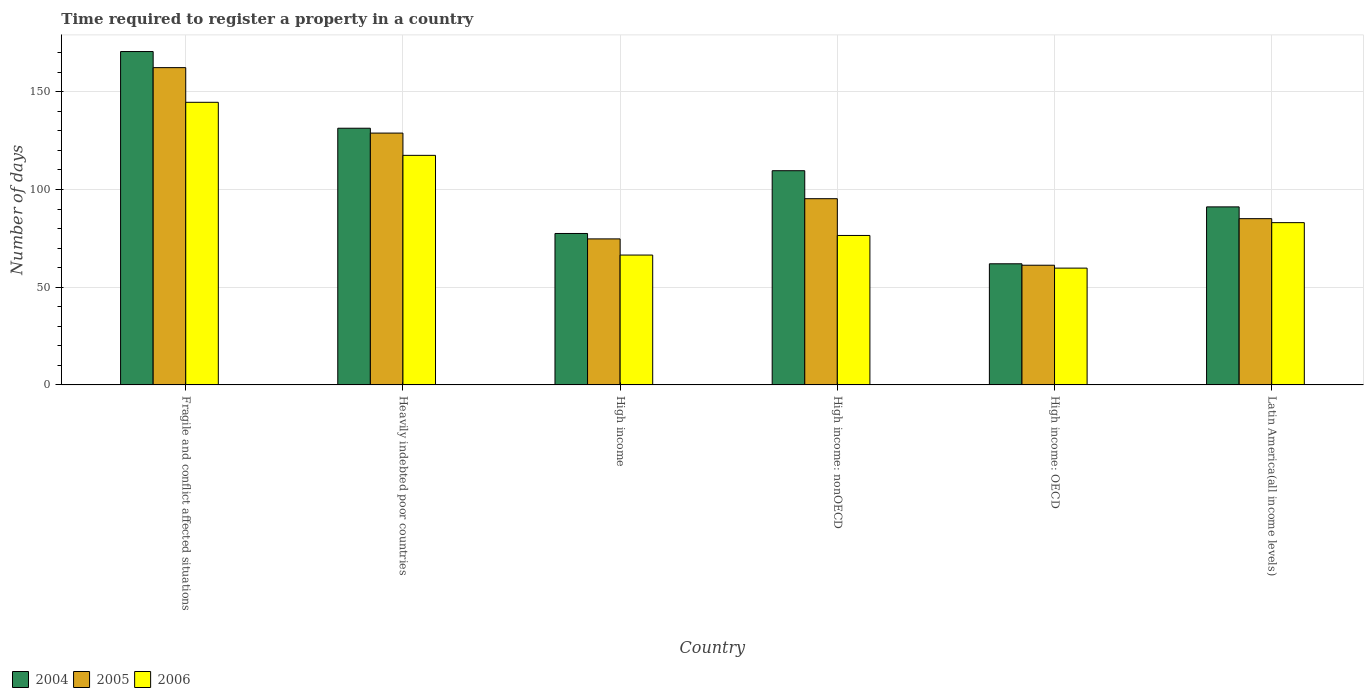Are the number of bars per tick equal to the number of legend labels?
Offer a terse response. Yes. How many bars are there on the 4th tick from the right?
Provide a short and direct response. 3. What is the label of the 1st group of bars from the left?
Provide a succinct answer. Fragile and conflict affected situations. What is the number of days required to register a property in 2006 in High income?
Provide a succinct answer. 66.45. Across all countries, what is the maximum number of days required to register a property in 2004?
Offer a terse response. 170.59. Across all countries, what is the minimum number of days required to register a property in 2005?
Ensure brevity in your answer.  61.24. In which country was the number of days required to register a property in 2006 maximum?
Your answer should be compact. Fragile and conflict affected situations. In which country was the number of days required to register a property in 2005 minimum?
Provide a short and direct response. High income: OECD. What is the total number of days required to register a property in 2004 in the graph?
Your answer should be compact. 642.12. What is the difference between the number of days required to register a property in 2005 in Fragile and conflict affected situations and that in Latin America(all income levels)?
Your answer should be very brief. 77.29. What is the difference between the number of days required to register a property in 2006 in High income: OECD and the number of days required to register a property in 2005 in Heavily indebted poor countries?
Your response must be concise. -69.1. What is the average number of days required to register a property in 2005 per country?
Make the answer very short. 101.26. What is the difference between the number of days required to register a property of/in 2004 and number of days required to register a property of/in 2006 in High income: OECD?
Your answer should be very brief. 2.22. In how many countries, is the number of days required to register a property in 2005 greater than 140 days?
Keep it short and to the point. 1. What is the ratio of the number of days required to register a property in 2006 in High income: OECD to that in Latin America(all income levels)?
Ensure brevity in your answer.  0.72. Is the number of days required to register a property in 2005 in Heavily indebted poor countries less than that in High income: OECD?
Ensure brevity in your answer.  No. Is the difference between the number of days required to register a property in 2004 in High income and High income: OECD greater than the difference between the number of days required to register a property in 2006 in High income and High income: OECD?
Ensure brevity in your answer.  Yes. What is the difference between the highest and the second highest number of days required to register a property in 2006?
Keep it short and to the point. 61.58. What is the difference between the highest and the lowest number of days required to register a property in 2005?
Your answer should be compact. 101.12. In how many countries, is the number of days required to register a property in 2004 greater than the average number of days required to register a property in 2004 taken over all countries?
Provide a short and direct response. 3. What does the 2nd bar from the right in Heavily indebted poor countries represents?
Your answer should be very brief. 2005. Is it the case that in every country, the sum of the number of days required to register a property in 2006 and number of days required to register a property in 2005 is greater than the number of days required to register a property in 2004?
Offer a terse response. Yes. How many bars are there?
Offer a terse response. 18. How many countries are there in the graph?
Your answer should be compact. 6. Are the values on the major ticks of Y-axis written in scientific E-notation?
Offer a terse response. No. Does the graph contain any zero values?
Your answer should be very brief. No. How many legend labels are there?
Your response must be concise. 3. What is the title of the graph?
Provide a short and direct response. Time required to register a property in a country. Does "2001" appear as one of the legend labels in the graph?
Offer a very short reply. No. What is the label or title of the Y-axis?
Keep it short and to the point. Number of days. What is the Number of days in 2004 in Fragile and conflict affected situations?
Give a very brief answer. 170.59. What is the Number of days in 2005 in Fragile and conflict affected situations?
Your response must be concise. 162.36. What is the Number of days in 2006 in Fragile and conflict affected situations?
Ensure brevity in your answer.  144.62. What is the Number of days of 2004 in Heavily indebted poor countries?
Keep it short and to the point. 131.35. What is the Number of days of 2005 in Heavily indebted poor countries?
Provide a succinct answer. 128.86. What is the Number of days in 2006 in Heavily indebted poor countries?
Make the answer very short. 117.47. What is the Number of days in 2004 in High income?
Your answer should be compact. 77.49. What is the Number of days in 2005 in High income?
Ensure brevity in your answer.  74.72. What is the Number of days of 2006 in High income?
Your answer should be compact. 66.45. What is the Number of days of 2004 in High income: nonOECD?
Offer a very short reply. 109.61. What is the Number of days in 2005 in High income: nonOECD?
Your answer should be compact. 95.29. What is the Number of days in 2006 in High income: nonOECD?
Keep it short and to the point. 76.47. What is the Number of days of 2004 in High income: OECD?
Offer a terse response. 61.98. What is the Number of days in 2005 in High income: OECD?
Provide a succinct answer. 61.24. What is the Number of days in 2006 in High income: OECD?
Your answer should be very brief. 59.77. What is the Number of days in 2004 in Latin America(all income levels)?
Give a very brief answer. 91.1. What is the Number of days of 2005 in Latin America(all income levels)?
Provide a short and direct response. 85.07. What is the Number of days of 2006 in Latin America(all income levels)?
Provide a succinct answer. 83.03. Across all countries, what is the maximum Number of days of 2004?
Keep it short and to the point. 170.59. Across all countries, what is the maximum Number of days of 2005?
Your response must be concise. 162.36. Across all countries, what is the maximum Number of days of 2006?
Offer a terse response. 144.62. Across all countries, what is the minimum Number of days in 2004?
Your answer should be compact. 61.98. Across all countries, what is the minimum Number of days in 2005?
Provide a succinct answer. 61.24. Across all countries, what is the minimum Number of days of 2006?
Keep it short and to the point. 59.77. What is the total Number of days of 2004 in the graph?
Provide a short and direct response. 642.12. What is the total Number of days in 2005 in the graph?
Keep it short and to the point. 607.54. What is the total Number of days of 2006 in the graph?
Ensure brevity in your answer.  547.82. What is the difference between the Number of days in 2004 in Fragile and conflict affected situations and that in Heavily indebted poor countries?
Your answer should be compact. 39.24. What is the difference between the Number of days in 2005 in Fragile and conflict affected situations and that in Heavily indebted poor countries?
Your response must be concise. 33.5. What is the difference between the Number of days in 2006 in Fragile and conflict affected situations and that in Heavily indebted poor countries?
Offer a terse response. 27.14. What is the difference between the Number of days of 2004 in Fragile and conflict affected situations and that in High income?
Your response must be concise. 93.1. What is the difference between the Number of days in 2005 in Fragile and conflict affected situations and that in High income?
Your answer should be very brief. 87.64. What is the difference between the Number of days of 2006 in Fragile and conflict affected situations and that in High income?
Give a very brief answer. 78.17. What is the difference between the Number of days of 2004 in Fragile and conflict affected situations and that in High income: nonOECD?
Ensure brevity in your answer.  60.98. What is the difference between the Number of days in 2005 in Fragile and conflict affected situations and that in High income: nonOECD?
Your response must be concise. 67.07. What is the difference between the Number of days in 2006 in Fragile and conflict affected situations and that in High income: nonOECD?
Make the answer very short. 68.14. What is the difference between the Number of days in 2004 in Fragile and conflict affected situations and that in High income: OECD?
Ensure brevity in your answer.  108.61. What is the difference between the Number of days of 2005 in Fragile and conflict affected situations and that in High income: OECD?
Offer a terse response. 101.12. What is the difference between the Number of days in 2006 in Fragile and conflict affected situations and that in High income: OECD?
Make the answer very short. 84.85. What is the difference between the Number of days of 2004 in Fragile and conflict affected situations and that in Latin America(all income levels)?
Keep it short and to the point. 79.49. What is the difference between the Number of days of 2005 in Fragile and conflict affected situations and that in Latin America(all income levels)?
Give a very brief answer. 77.29. What is the difference between the Number of days in 2006 in Fragile and conflict affected situations and that in Latin America(all income levels)?
Ensure brevity in your answer.  61.58. What is the difference between the Number of days of 2004 in Heavily indebted poor countries and that in High income?
Your answer should be very brief. 53.86. What is the difference between the Number of days of 2005 in Heavily indebted poor countries and that in High income?
Provide a short and direct response. 54.15. What is the difference between the Number of days of 2006 in Heavily indebted poor countries and that in High income?
Offer a terse response. 51.02. What is the difference between the Number of days of 2004 in Heavily indebted poor countries and that in High income: nonOECD?
Provide a succinct answer. 21.75. What is the difference between the Number of days in 2005 in Heavily indebted poor countries and that in High income: nonOECD?
Give a very brief answer. 33.58. What is the difference between the Number of days of 2006 in Heavily indebted poor countries and that in High income: nonOECD?
Make the answer very short. 41. What is the difference between the Number of days of 2004 in Heavily indebted poor countries and that in High income: OECD?
Your answer should be compact. 69.37. What is the difference between the Number of days in 2005 in Heavily indebted poor countries and that in High income: OECD?
Offer a terse response. 67.62. What is the difference between the Number of days in 2006 in Heavily indebted poor countries and that in High income: OECD?
Ensure brevity in your answer.  57.71. What is the difference between the Number of days of 2004 in Heavily indebted poor countries and that in Latin America(all income levels)?
Your answer should be very brief. 40.25. What is the difference between the Number of days of 2005 in Heavily indebted poor countries and that in Latin America(all income levels)?
Give a very brief answer. 43.8. What is the difference between the Number of days of 2006 in Heavily indebted poor countries and that in Latin America(all income levels)?
Your answer should be compact. 34.44. What is the difference between the Number of days of 2004 in High income and that in High income: nonOECD?
Offer a very short reply. -32.12. What is the difference between the Number of days of 2005 in High income and that in High income: nonOECD?
Offer a very short reply. -20.57. What is the difference between the Number of days of 2006 in High income and that in High income: nonOECD?
Your answer should be compact. -10.03. What is the difference between the Number of days of 2004 in High income and that in High income: OECD?
Make the answer very short. 15.51. What is the difference between the Number of days in 2005 in High income and that in High income: OECD?
Give a very brief answer. 13.48. What is the difference between the Number of days in 2006 in High income and that in High income: OECD?
Offer a very short reply. 6.68. What is the difference between the Number of days in 2004 in High income and that in Latin America(all income levels)?
Your response must be concise. -13.61. What is the difference between the Number of days in 2005 in High income and that in Latin America(all income levels)?
Make the answer very short. -10.35. What is the difference between the Number of days in 2006 in High income and that in Latin America(all income levels)?
Provide a succinct answer. -16.58. What is the difference between the Number of days in 2004 in High income: nonOECD and that in High income: OECD?
Provide a short and direct response. 47.62. What is the difference between the Number of days of 2005 in High income: nonOECD and that in High income: OECD?
Provide a short and direct response. 34.05. What is the difference between the Number of days of 2006 in High income: nonOECD and that in High income: OECD?
Keep it short and to the point. 16.71. What is the difference between the Number of days of 2004 in High income: nonOECD and that in Latin America(all income levels)?
Ensure brevity in your answer.  18.51. What is the difference between the Number of days in 2005 in High income: nonOECD and that in Latin America(all income levels)?
Offer a terse response. 10.22. What is the difference between the Number of days of 2006 in High income: nonOECD and that in Latin America(all income levels)?
Ensure brevity in your answer.  -6.56. What is the difference between the Number of days in 2004 in High income: OECD and that in Latin America(all income levels)?
Give a very brief answer. -29.12. What is the difference between the Number of days in 2005 in High income: OECD and that in Latin America(all income levels)?
Your answer should be compact. -23.83. What is the difference between the Number of days of 2006 in High income: OECD and that in Latin America(all income levels)?
Offer a terse response. -23.27. What is the difference between the Number of days in 2004 in Fragile and conflict affected situations and the Number of days in 2005 in Heavily indebted poor countries?
Offer a very short reply. 41.73. What is the difference between the Number of days in 2004 in Fragile and conflict affected situations and the Number of days in 2006 in Heavily indebted poor countries?
Offer a very short reply. 53.12. What is the difference between the Number of days in 2005 in Fragile and conflict affected situations and the Number of days in 2006 in Heavily indebted poor countries?
Provide a short and direct response. 44.89. What is the difference between the Number of days of 2004 in Fragile and conflict affected situations and the Number of days of 2005 in High income?
Provide a short and direct response. 95.87. What is the difference between the Number of days of 2004 in Fragile and conflict affected situations and the Number of days of 2006 in High income?
Offer a terse response. 104.14. What is the difference between the Number of days in 2005 in Fragile and conflict affected situations and the Number of days in 2006 in High income?
Make the answer very short. 95.91. What is the difference between the Number of days of 2004 in Fragile and conflict affected situations and the Number of days of 2005 in High income: nonOECD?
Give a very brief answer. 75.3. What is the difference between the Number of days of 2004 in Fragile and conflict affected situations and the Number of days of 2006 in High income: nonOECD?
Offer a terse response. 94.12. What is the difference between the Number of days of 2005 in Fragile and conflict affected situations and the Number of days of 2006 in High income: nonOECD?
Make the answer very short. 85.89. What is the difference between the Number of days of 2004 in Fragile and conflict affected situations and the Number of days of 2005 in High income: OECD?
Provide a succinct answer. 109.35. What is the difference between the Number of days in 2004 in Fragile and conflict affected situations and the Number of days in 2006 in High income: OECD?
Keep it short and to the point. 110.82. What is the difference between the Number of days of 2005 in Fragile and conflict affected situations and the Number of days of 2006 in High income: OECD?
Give a very brief answer. 102.59. What is the difference between the Number of days in 2004 in Fragile and conflict affected situations and the Number of days in 2005 in Latin America(all income levels)?
Make the answer very short. 85.52. What is the difference between the Number of days of 2004 in Fragile and conflict affected situations and the Number of days of 2006 in Latin America(all income levels)?
Your answer should be compact. 87.56. What is the difference between the Number of days of 2005 in Fragile and conflict affected situations and the Number of days of 2006 in Latin America(all income levels)?
Offer a very short reply. 79.33. What is the difference between the Number of days of 2004 in Heavily indebted poor countries and the Number of days of 2005 in High income?
Your answer should be very brief. 56.63. What is the difference between the Number of days in 2004 in Heavily indebted poor countries and the Number of days in 2006 in High income?
Offer a very short reply. 64.9. What is the difference between the Number of days of 2005 in Heavily indebted poor countries and the Number of days of 2006 in High income?
Give a very brief answer. 62.41. What is the difference between the Number of days of 2004 in Heavily indebted poor countries and the Number of days of 2005 in High income: nonOECD?
Provide a short and direct response. 36.06. What is the difference between the Number of days in 2004 in Heavily indebted poor countries and the Number of days in 2006 in High income: nonOECD?
Make the answer very short. 54.88. What is the difference between the Number of days in 2005 in Heavily indebted poor countries and the Number of days in 2006 in High income: nonOECD?
Offer a very short reply. 52.39. What is the difference between the Number of days in 2004 in Heavily indebted poor countries and the Number of days in 2005 in High income: OECD?
Keep it short and to the point. 70.11. What is the difference between the Number of days of 2004 in Heavily indebted poor countries and the Number of days of 2006 in High income: OECD?
Offer a terse response. 71.59. What is the difference between the Number of days in 2005 in Heavily indebted poor countries and the Number of days in 2006 in High income: OECD?
Your answer should be very brief. 69.1. What is the difference between the Number of days of 2004 in Heavily indebted poor countries and the Number of days of 2005 in Latin America(all income levels)?
Offer a very short reply. 46.28. What is the difference between the Number of days of 2004 in Heavily indebted poor countries and the Number of days of 2006 in Latin America(all income levels)?
Your answer should be compact. 48.32. What is the difference between the Number of days of 2005 in Heavily indebted poor countries and the Number of days of 2006 in Latin America(all income levels)?
Keep it short and to the point. 45.83. What is the difference between the Number of days of 2004 in High income and the Number of days of 2005 in High income: nonOECD?
Offer a terse response. -17.8. What is the difference between the Number of days of 2004 in High income and the Number of days of 2006 in High income: nonOECD?
Offer a very short reply. 1.01. What is the difference between the Number of days in 2005 in High income and the Number of days in 2006 in High income: nonOECD?
Ensure brevity in your answer.  -1.76. What is the difference between the Number of days in 2004 in High income and the Number of days in 2005 in High income: OECD?
Provide a short and direct response. 16.25. What is the difference between the Number of days in 2004 in High income and the Number of days in 2006 in High income: OECD?
Offer a terse response. 17.72. What is the difference between the Number of days in 2005 in High income and the Number of days in 2006 in High income: OECD?
Give a very brief answer. 14.95. What is the difference between the Number of days in 2004 in High income and the Number of days in 2005 in Latin America(all income levels)?
Ensure brevity in your answer.  -7.58. What is the difference between the Number of days of 2004 in High income and the Number of days of 2006 in Latin America(all income levels)?
Your response must be concise. -5.55. What is the difference between the Number of days in 2005 in High income and the Number of days in 2006 in Latin America(all income levels)?
Make the answer very short. -8.32. What is the difference between the Number of days of 2004 in High income: nonOECD and the Number of days of 2005 in High income: OECD?
Provide a short and direct response. 48.37. What is the difference between the Number of days in 2004 in High income: nonOECD and the Number of days in 2006 in High income: OECD?
Make the answer very short. 49.84. What is the difference between the Number of days of 2005 in High income: nonOECD and the Number of days of 2006 in High income: OECD?
Your response must be concise. 35.52. What is the difference between the Number of days in 2004 in High income: nonOECD and the Number of days in 2005 in Latin America(all income levels)?
Ensure brevity in your answer.  24.54. What is the difference between the Number of days of 2004 in High income: nonOECD and the Number of days of 2006 in Latin America(all income levels)?
Your response must be concise. 26.57. What is the difference between the Number of days in 2005 in High income: nonOECD and the Number of days in 2006 in Latin America(all income levels)?
Give a very brief answer. 12.26. What is the difference between the Number of days of 2004 in High income: OECD and the Number of days of 2005 in Latin America(all income levels)?
Keep it short and to the point. -23.09. What is the difference between the Number of days of 2004 in High income: OECD and the Number of days of 2006 in Latin America(all income levels)?
Give a very brief answer. -21.05. What is the difference between the Number of days of 2005 in High income: OECD and the Number of days of 2006 in Latin America(all income levels)?
Provide a succinct answer. -21.79. What is the average Number of days in 2004 per country?
Keep it short and to the point. 107.02. What is the average Number of days of 2005 per country?
Your response must be concise. 101.26. What is the average Number of days of 2006 per country?
Your answer should be very brief. 91.3. What is the difference between the Number of days in 2004 and Number of days in 2005 in Fragile and conflict affected situations?
Your answer should be compact. 8.23. What is the difference between the Number of days of 2004 and Number of days of 2006 in Fragile and conflict affected situations?
Give a very brief answer. 25.98. What is the difference between the Number of days of 2005 and Number of days of 2006 in Fragile and conflict affected situations?
Offer a terse response. 17.74. What is the difference between the Number of days of 2004 and Number of days of 2005 in Heavily indebted poor countries?
Ensure brevity in your answer.  2.49. What is the difference between the Number of days of 2004 and Number of days of 2006 in Heavily indebted poor countries?
Offer a terse response. 13.88. What is the difference between the Number of days in 2005 and Number of days in 2006 in Heavily indebted poor countries?
Provide a short and direct response. 11.39. What is the difference between the Number of days in 2004 and Number of days in 2005 in High income?
Ensure brevity in your answer.  2.77. What is the difference between the Number of days in 2004 and Number of days in 2006 in High income?
Keep it short and to the point. 11.04. What is the difference between the Number of days in 2005 and Number of days in 2006 in High income?
Provide a short and direct response. 8.27. What is the difference between the Number of days in 2004 and Number of days in 2005 in High income: nonOECD?
Your answer should be compact. 14.32. What is the difference between the Number of days of 2004 and Number of days of 2006 in High income: nonOECD?
Offer a terse response. 33.13. What is the difference between the Number of days of 2005 and Number of days of 2006 in High income: nonOECD?
Your response must be concise. 18.81. What is the difference between the Number of days of 2004 and Number of days of 2005 in High income: OECD?
Offer a very short reply. 0.74. What is the difference between the Number of days in 2004 and Number of days in 2006 in High income: OECD?
Keep it short and to the point. 2.22. What is the difference between the Number of days of 2005 and Number of days of 2006 in High income: OECD?
Your answer should be very brief. 1.47. What is the difference between the Number of days in 2004 and Number of days in 2005 in Latin America(all income levels)?
Offer a very short reply. 6.03. What is the difference between the Number of days in 2004 and Number of days in 2006 in Latin America(all income levels)?
Ensure brevity in your answer.  8.07. What is the difference between the Number of days in 2005 and Number of days in 2006 in Latin America(all income levels)?
Provide a succinct answer. 2.03. What is the ratio of the Number of days of 2004 in Fragile and conflict affected situations to that in Heavily indebted poor countries?
Offer a terse response. 1.3. What is the ratio of the Number of days in 2005 in Fragile and conflict affected situations to that in Heavily indebted poor countries?
Ensure brevity in your answer.  1.26. What is the ratio of the Number of days of 2006 in Fragile and conflict affected situations to that in Heavily indebted poor countries?
Offer a terse response. 1.23. What is the ratio of the Number of days of 2004 in Fragile and conflict affected situations to that in High income?
Offer a very short reply. 2.2. What is the ratio of the Number of days of 2005 in Fragile and conflict affected situations to that in High income?
Your answer should be very brief. 2.17. What is the ratio of the Number of days in 2006 in Fragile and conflict affected situations to that in High income?
Your answer should be very brief. 2.18. What is the ratio of the Number of days of 2004 in Fragile and conflict affected situations to that in High income: nonOECD?
Your answer should be very brief. 1.56. What is the ratio of the Number of days in 2005 in Fragile and conflict affected situations to that in High income: nonOECD?
Your answer should be compact. 1.7. What is the ratio of the Number of days of 2006 in Fragile and conflict affected situations to that in High income: nonOECD?
Keep it short and to the point. 1.89. What is the ratio of the Number of days of 2004 in Fragile and conflict affected situations to that in High income: OECD?
Give a very brief answer. 2.75. What is the ratio of the Number of days in 2005 in Fragile and conflict affected situations to that in High income: OECD?
Your response must be concise. 2.65. What is the ratio of the Number of days in 2006 in Fragile and conflict affected situations to that in High income: OECD?
Keep it short and to the point. 2.42. What is the ratio of the Number of days in 2004 in Fragile and conflict affected situations to that in Latin America(all income levels)?
Keep it short and to the point. 1.87. What is the ratio of the Number of days in 2005 in Fragile and conflict affected situations to that in Latin America(all income levels)?
Your answer should be very brief. 1.91. What is the ratio of the Number of days of 2006 in Fragile and conflict affected situations to that in Latin America(all income levels)?
Provide a short and direct response. 1.74. What is the ratio of the Number of days of 2004 in Heavily indebted poor countries to that in High income?
Your answer should be very brief. 1.7. What is the ratio of the Number of days in 2005 in Heavily indebted poor countries to that in High income?
Offer a terse response. 1.72. What is the ratio of the Number of days in 2006 in Heavily indebted poor countries to that in High income?
Provide a succinct answer. 1.77. What is the ratio of the Number of days in 2004 in Heavily indebted poor countries to that in High income: nonOECD?
Your answer should be compact. 1.2. What is the ratio of the Number of days in 2005 in Heavily indebted poor countries to that in High income: nonOECD?
Make the answer very short. 1.35. What is the ratio of the Number of days in 2006 in Heavily indebted poor countries to that in High income: nonOECD?
Provide a short and direct response. 1.54. What is the ratio of the Number of days in 2004 in Heavily indebted poor countries to that in High income: OECD?
Ensure brevity in your answer.  2.12. What is the ratio of the Number of days of 2005 in Heavily indebted poor countries to that in High income: OECD?
Provide a succinct answer. 2.1. What is the ratio of the Number of days of 2006 in Heavily indebted poor countries to that in High income: OECD?
Keep it short and to the point. 1.97. What is the ratio of the Number of days in 2004 in Heavily indebted poor countries to that in Latin America(all income levels)?
Your answer should be very brief. 1.44. What is the ratio of the Number of days in 2005 in Heavily indebted poor countries to that in Latin America(all income levels)?
Offer a terse response. 1.51. What is the ratio of the Number of days of 2006 in Heavily indebted poor countries to that in Latin America(all income levels)?
Offer a terse response. 1.41. What is the ratio of the Number of days in 2004 in High income to that in High income: nonOECD?
Make the answer very short. 0.71. What is the ratio of the Number of days in 2005 in High income to that in High income: nonOECD?
Offer a very short reply. 0.78. What is the ratio of the Number of days in 2006 in High income to that in High income: nonOECD?
Offer a terse response. 0.87. What is the ratio of the Number of days of 2004 in High income to that in High income: OECD?
Make the answer very short. 1.25. What is the ratio of the Number of days of 2005 in High income to that in High income: OECD?
Your answer should be compact. 1.22. What is the ratio of the Number of days of 2006 in High income to that in High income: OECD?
Ensure brevity in your answer.  1.11. What is the ratio of the Number of days of 2004 in High income to that in Latin America(all income levels)?
Give a very brief answer. 0.85. What is the ratio of the Number of days in 2005 in High income to that in Latin America(all income levels)?
Your answer should be compact. 0.88. What is the ratio of the Number of days of 2006 in High income to that in Latin America(all income levels)?
Your answer should be very brief. 0.8. What is the ratio of the Number of days in 2004 in High income: nonOECD to that in High income: OECD?
Your answer should be compact. 1.77. What is the ratio of the Number of days in 2005 in High income: nonOECD to that in High income: OECD?
Ensure brevity in your answer.  1.56. What is the ratio of the Number of days of 2006 in High income: nonOECD to that in High income: OECD?
Make the answer very short. 1.28. What is the ratio of the Number of days of 2004 in High income: nonOECD to that in Latin America(all income levels)?
Your answer should be very brief. 1.2. What is the ratio of the Number of days in 2005 in High income: nonOECD to that in Latin America(all income levels)?
Keep it short and to the point. 1.12. What is the ratio of the Number of days in 2006 in High income: nonOECD to that in Latin America(all income levels)?
Keep it short and to the point. 0.92. What is the ratio of the Number of days of 2004 in High income: OECD to that in Latin America(all income levels)?
Ensure brevity in your answer.  0.68. What is the ratio of the Number of days of 2005 in High income: OECD to that in Latin America(all income levels)?
Keep it short and to the point. 0.72. What is the ratio of the Number of days of 2006 in High income: OECD to that in Latin America(all income levels)?
Your answer should be very brief. 0.72. What is the difference between the highest and the second highest Number of days in 2004?
Give a very brief answer. 39.24. What is the difference between the highest and the second highest Number of days of 2005?
Keep it short and to the point. 33.5. What is the difference between the highest and the second highest Number of days in 2006?
Provide a succinct answer. 27.14. What is the difference between the highest and the lowest Number of days in 2004?
Offer a very short reply. 108.61. What is the difference between the highest and the lowest Number of days of 2005?
Keep it short and to the point. 101.12. What is the difference between the highest and the lowest Number of days of 2006?
Make the answer very short. 84.85. 